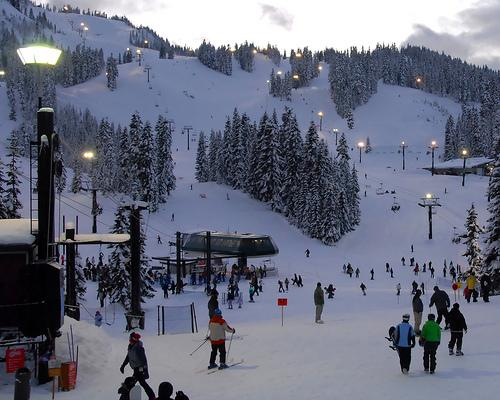What does this scene look most like? winter wonderland 